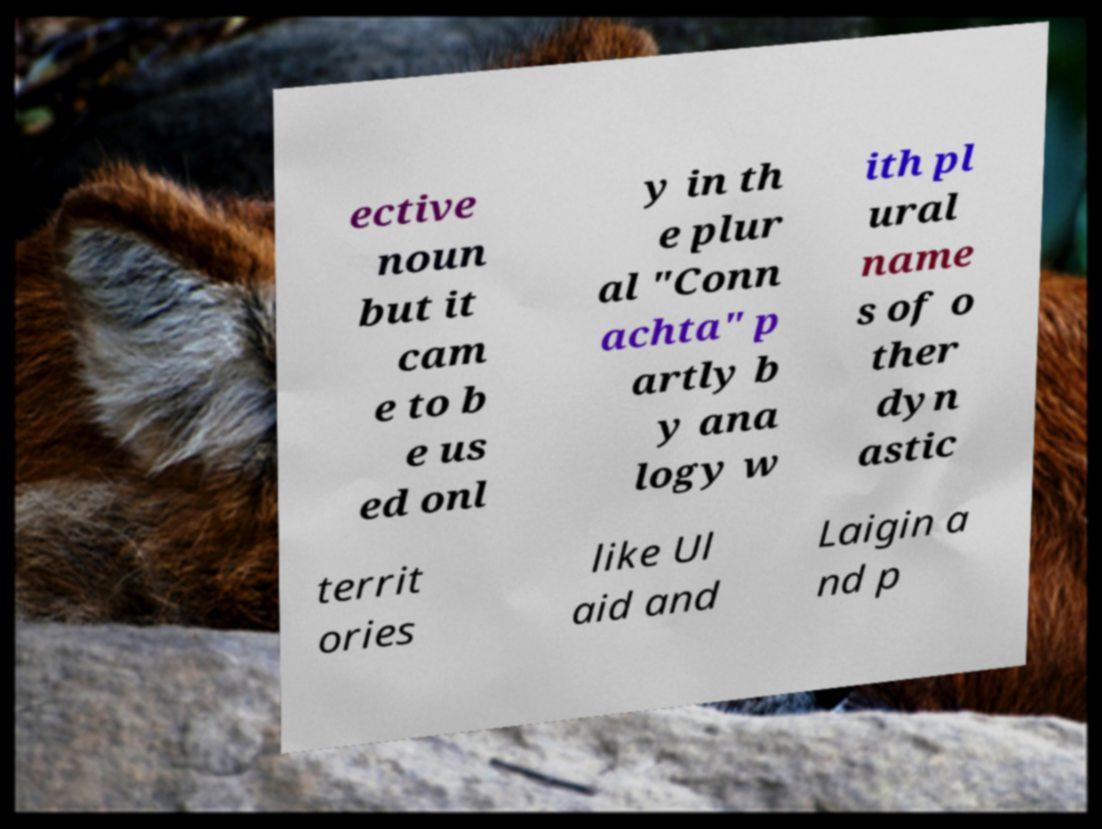I need the written content from this picture converted into text. Can you do that? ective noun but it cam e to b e us ed onl y in th e plur al "Conn achta" p artly b y ana logy w ith pl ural name s of o ther dyn astic territ ories like Ul aid and Laigin a nd p 